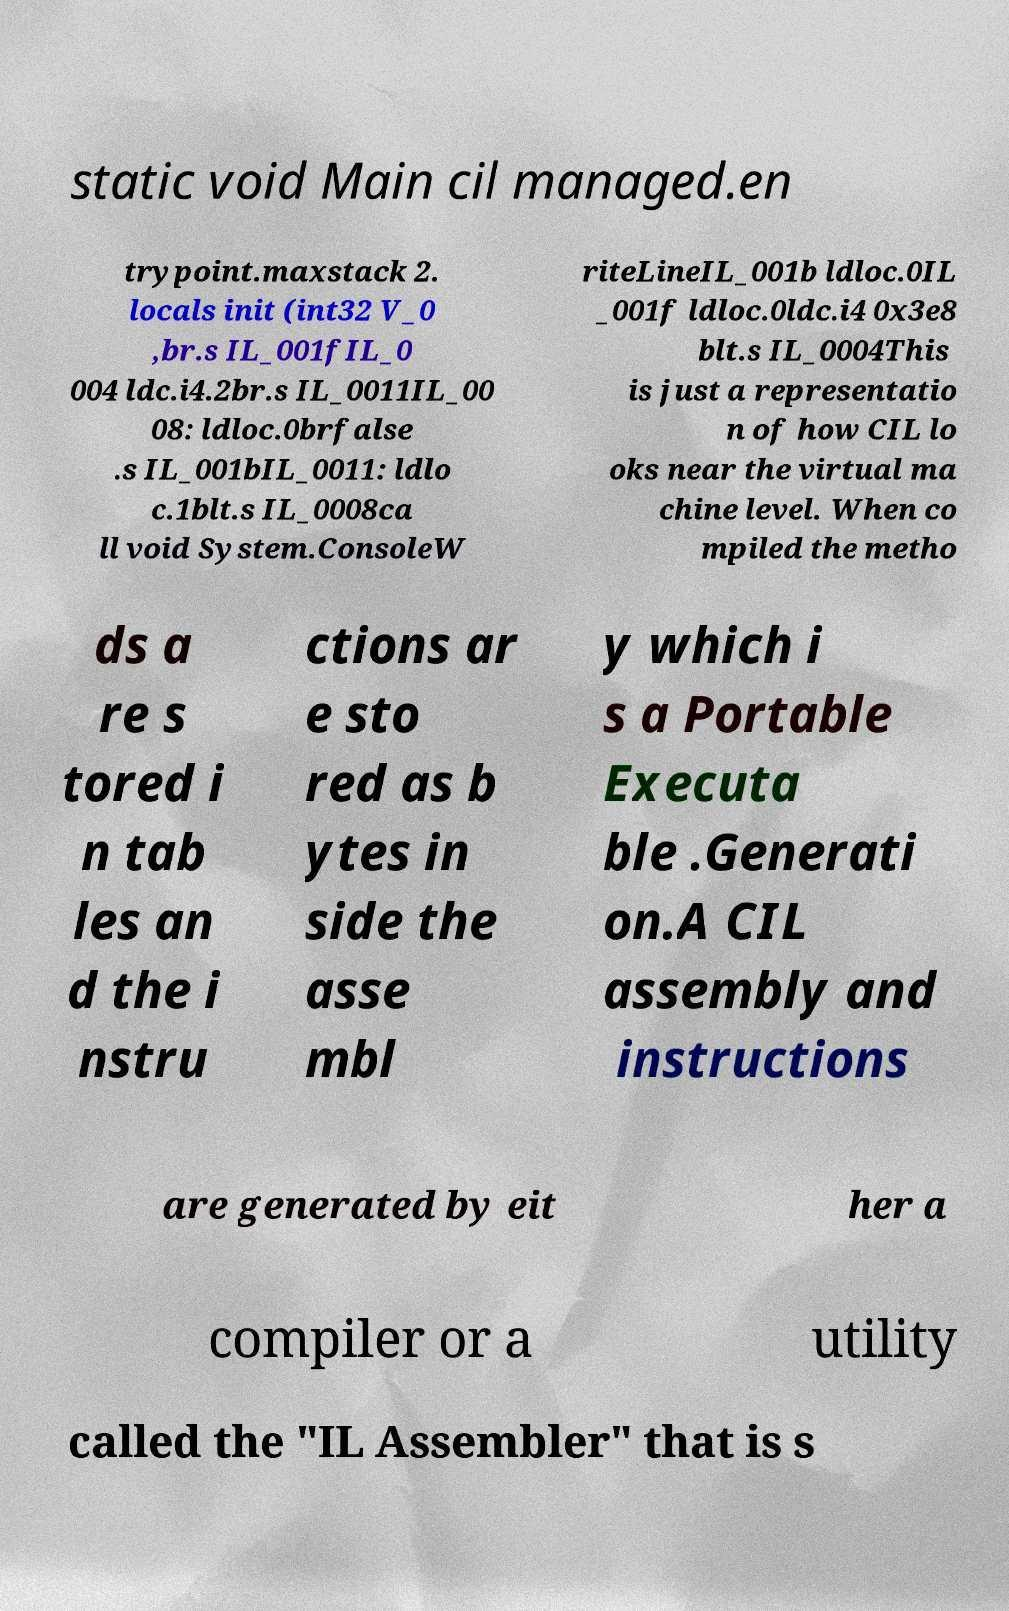Please identify and transcribe the text found in this image. static void Main cil managed.en trypoint.maxstack 2. locals init (int32 V_0 ,br.s IL_001fIL_0 004 ldc.i4.2br.s IL_0011IL_00 08: ldloc.0brfalse .s IL_001bIL_0011: ldlo c.1blt.s IL_0008ca ll void System.ConsoleW riteLineIL_001b ldloc.0IL _001f ldloc.0ldc.i4 0x3e8 blt.s IL_0004This is just a representatio n of how CIL lo oks near the virtual ma chine level. When co mpiled the metho ds a re s tored i n tab les an d the i nstru ctions ar e sto red as b ytes in side the asse mbl y which i s a Portable Executa ble .Generati on.A CIL assembly and instructions are generated by eit her a compiler or a utility called the "IL Assembler" that is s 